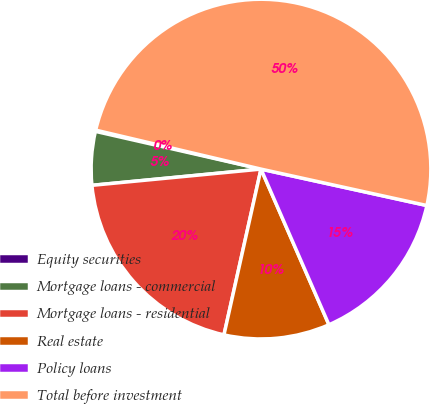Convert chart to OTSL. <chart><loc_0><loc_0><loc_500><loc_500><pie_chart><fcel>Equity securities<fcel>Mortgage loans - commercial<fcel>Mortgage loans - residential<fcel>Real estate<fcel>Policy loans<fcel>Total before investment<nl><fcel>0.12%<fcel>5.09%<fcel>19.98%<fcel>10.05%<fcel>15.01%<fcel>49.76%<nl></chart> 